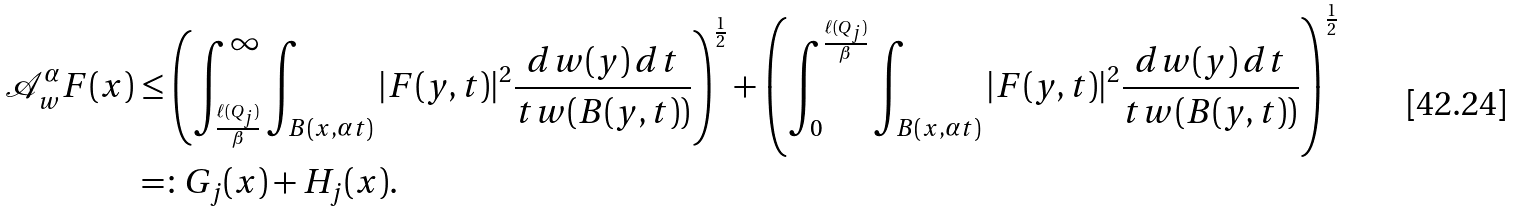Convert formula to latex. <formula><loc_0><loc_0><loc_500><loc_500>\mathcal { A } _ { w } ^ { \alpha } F ( x ) & \leq \left ( \int _ { \frac { \ell ( Q _ { j } ) } { \beta } } ^ { \infty } \int _ { B ( x , \alpha t ) } | F ( y , t ) | ^ { 2 } \frac { d w ( y ) \, d t } { t w ( B ( y , t ) ) } \right ) ^ { \frac { 1 } { 2 } } + \left ( \int _ { 0 } ^ { \frac { \ell ( Q _ { j } ) } { \beta } } \int _ { B ( x , \alpha t ) } | F ( y , t ) | ^ { 2 } \frac { d w ( y ) \, d t } { t w ( B ( y , t ) ) } \right ) ^ { \frac { 1 } { 2 } } \\ & = \colon G _ { j } ( x ) + H _ { j } ( x ) .</formula> 